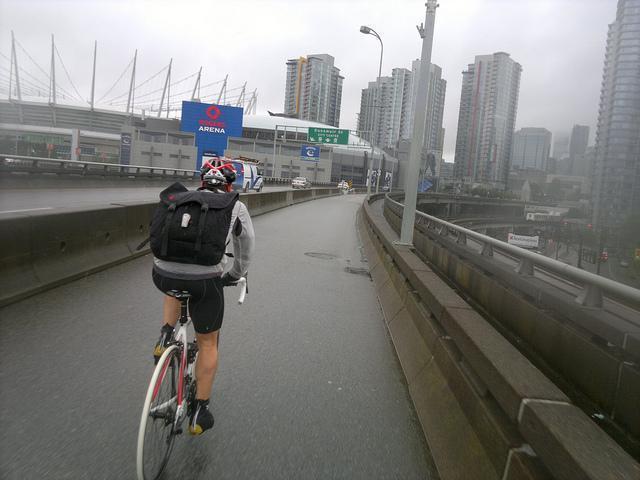What vehicles are allowed on the rightmost lane?
Indicate the correct choice and explain in the format: 'Answer: answer
Rationale: rationale.'
Options: Cars, trucks, vans, bicycles. Answer: bicycles.
Rationale: Bikes are only for the lane. 